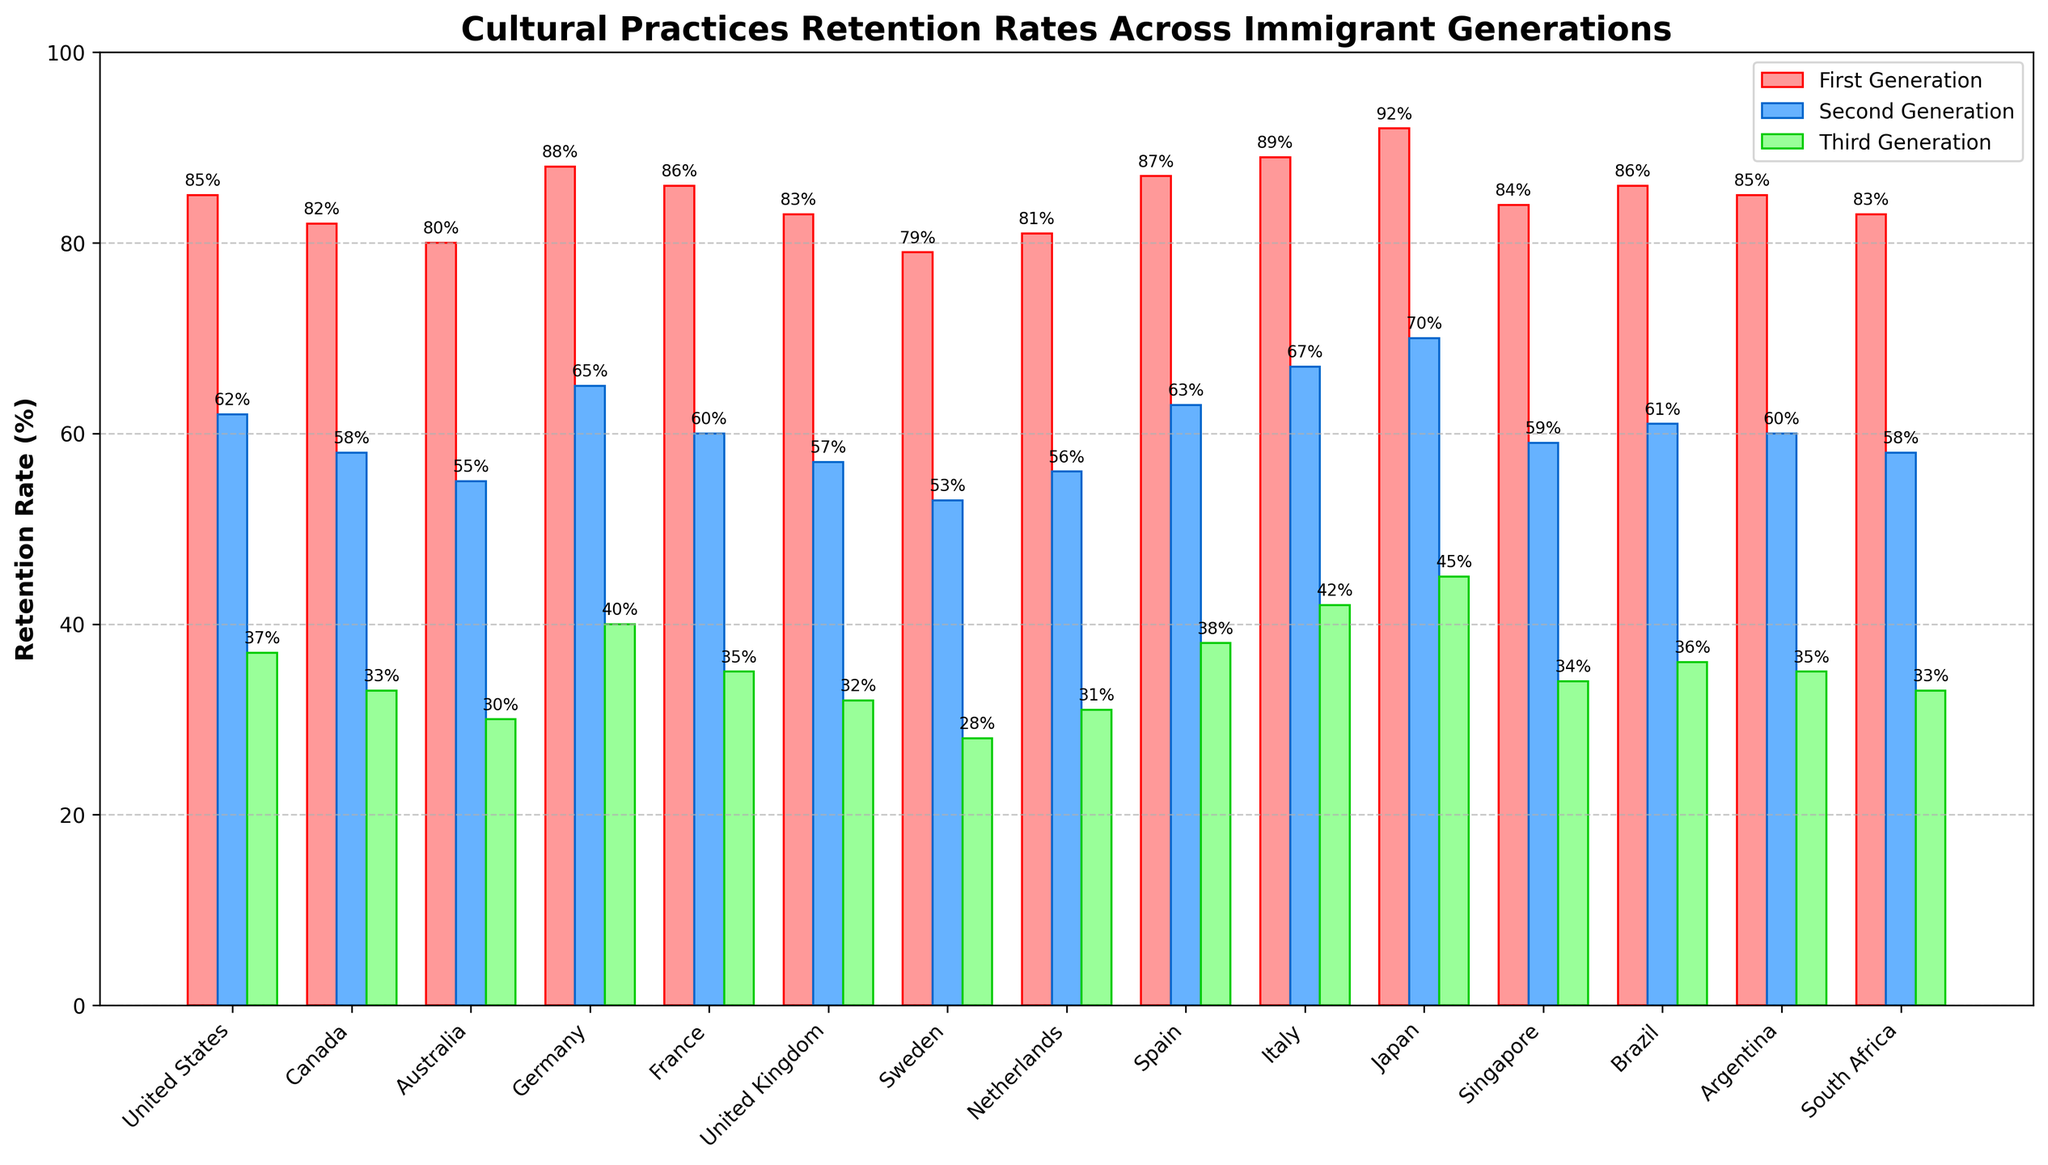Which country has the highest cultural practices retention rate for the first generation? The highest bar in the first generation group indicates the country with the highest retention rate. Japan has the highest bar for the first generation with a retention rate of 92%.
Answer: Japan Which country has the smallest decrease in cultural practices retention rate from the first to the second generation? To find the smallest decrease, we need to subtract the second generation retention rate from the first generation retention rate for each country and find the smallest difference. For Italy, the decrease is 89% - 67% = 22%, which is the smallest decrease among the countries.
Answer: Italy What is the average retention rate for the third generation across all countries? Sum the third generation retention rates for all countries and divide by the number of countries. The sum is (37 + 33 + 30 + 40 + 35 + 32 + 28 + 31 + 38 + 42 + 45 + 34 + 36 + 35 + 33) = 519. The number of countries is 15. So, the average is 519 / 15 ≈ 34.6%.
Answer: 34.6% Between Canada and the United Kingdom, which country shows a greater difference in retention rates between the first and third generations? Calculate the difference for both countries: Canada (82% - 33% = 49%) and United Kingdom (83% - 32% = 51%). The greater difference is for the United Kingdom.
Answer: United Kingdom Which generation generally shows the lowest retention rates across all countries? By observing the heights of the bars, the third generation consistently has the lowest retention rates across all countries.
Answer: Third generation Which countries have a greater than 70% retention rate for the second generation? Look at the height of the bars for the second generation. Only Japan has a retention rate above 70% for the second generation with 70%.
Answer: Japan What is the range of retention rates for the first generation across all countries? Identify the maximum and minimum retention rates for the first generation and subtract the minimum from the maximum. The maximum is Japan with 92%, and the minimum is Sweden with 79%. The range is 92% - 79% = 13%.
Answer: 13% Which country shows the smallest retention rate for the third generation? Find the country with the lowest height bar for the third generation. It is Sweden with a retention rate of 28%.
Answer: Sweden Compare and contrast the retention rates between Brazil and Argentina for all three generations. Which country has a more consistent pattern? For Brazil: 86%, 61%, 36%; for Argentina: 85%, 60%, 35%. Both countries have very similar retention rates, but Brazil shows a slightly more consistent pattern with uniform drops.
Answer: Brazil What is the total retention rate for the second generation in all countries combined? Sum the retention rates for the second generation across all countries: 62 + 58 + 55 + 65 + 60 + 57 + 53 + 56 + 63 + 67 + 70 + 59 + 61 + 60 + 58 = 904%.
Answer: 904% 